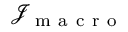<formula> <loc_0><loc_0><loc_500><loc_500>\mathcal { J } _ { m a c r o }</formula> 